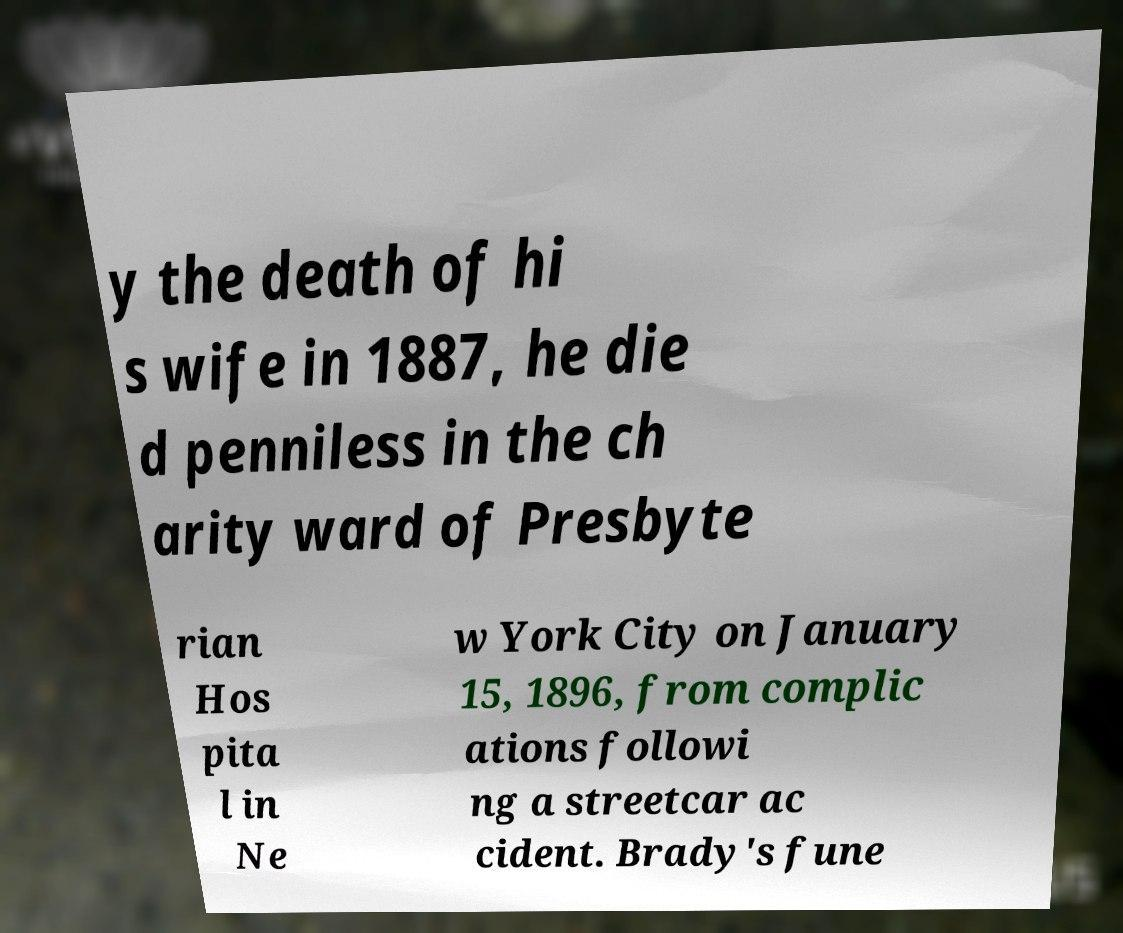For documentation purposes, I need the text within this image transcribed. Could you provide that? y the death of hi s wife in 1887, he die d penniless in the ch arity ward of Presbyte rian Hos pita l in Ne w York City on January 15, 1896, from complic ations followi ng a streetcar ac cident. Brady's fune 